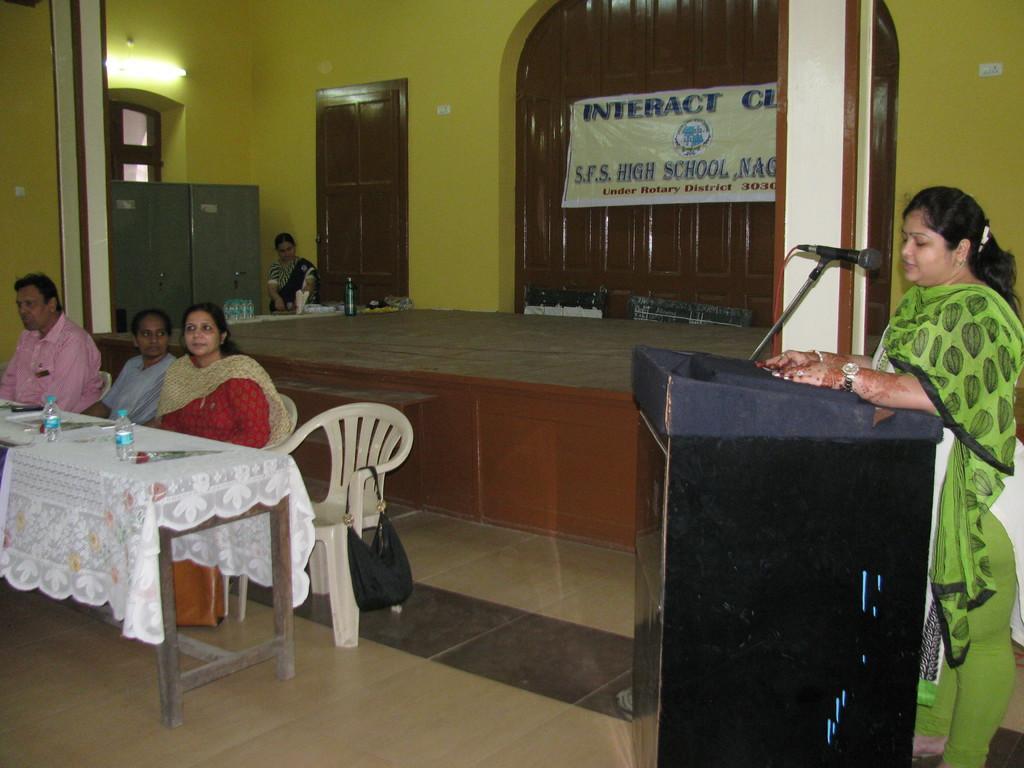Describe this image in one or two sentences. There is a room. On the left side we have three persons. The three people are sitting in a chair. There is a table. There is a bottle,rose flower on a table. On the right side we have a another woman. She is standing in front of her podium and she is speaking. At the corner side we have a another person she is standing. We can see in the background there is a yellow color wall,door and poster. 